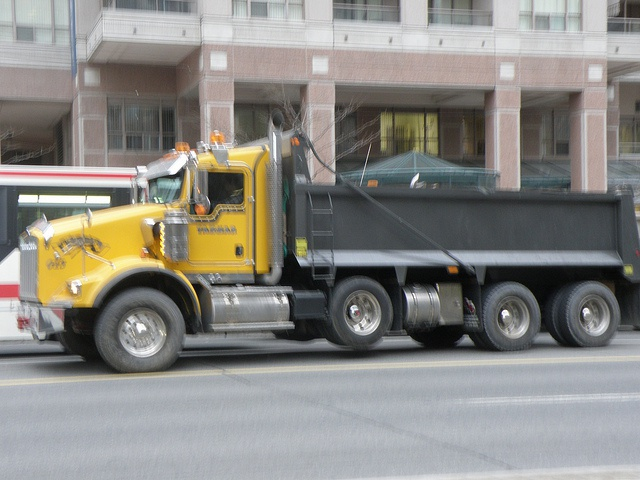Describe the objects in this image and their specific colors. I can see a truck in lightgray, gray, black, darkgray, and gold tones in this image. 